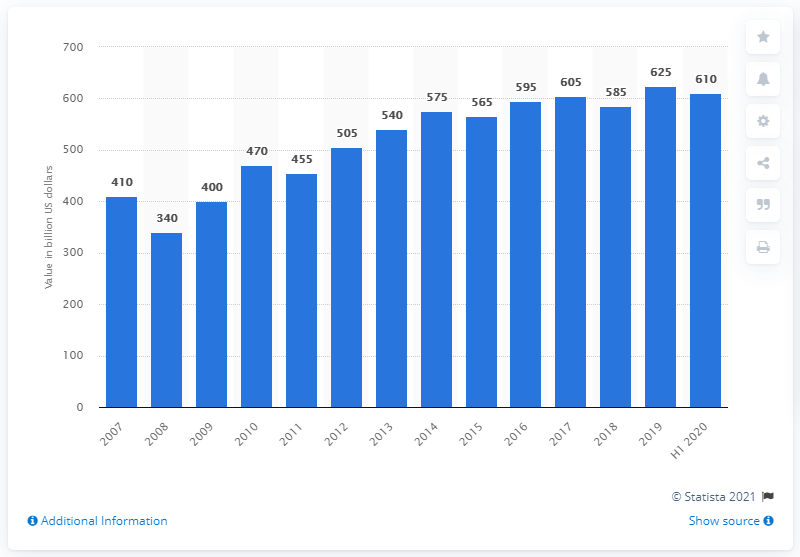Draw attention to some important aspects in this diagram. In the first half of 2020, global reinsurance capital was approximately 610 billion dollars. In the year 2008, the global financial crisis occurred. 